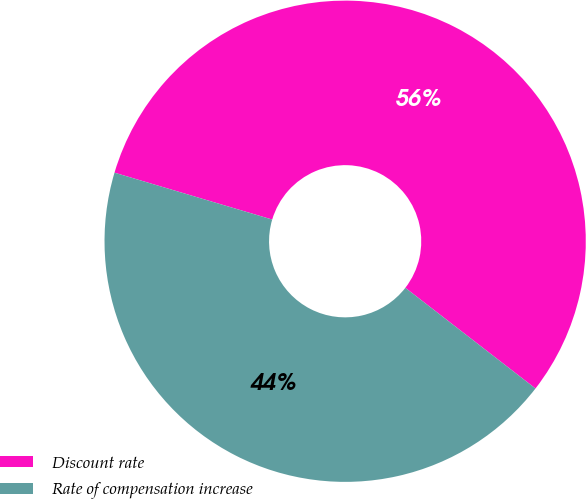Convert chart to OTSL. <chart><loc_0><loc_0><loc_500><loc_500><pie_chart><fcel>Discount rate<fcel>Rate of compensation increase<nl><fcel>55.88%<fcel>44.12%<nl></chart> 